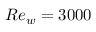<formula> <loc_0><loc_0><loc_500><loc_500>R e _ { w } = 3 0 0 0</formula> 